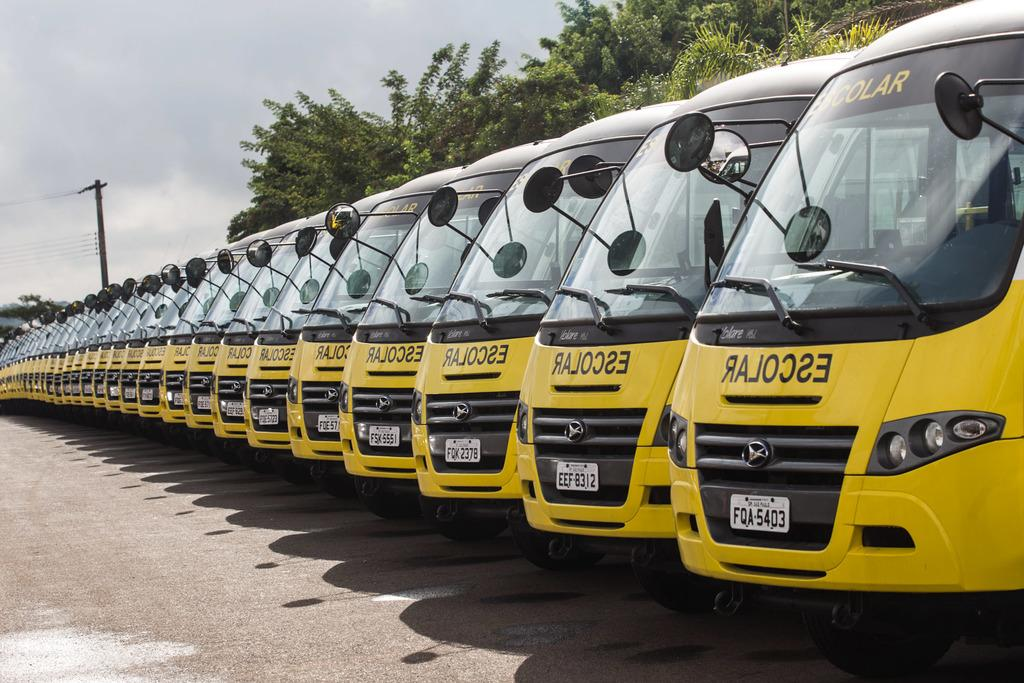What type of vehicles are in the image? There are buses in the image. What colors are the buses? The buses are in black and yellow color. What can be seen on the buses? Number-plates are visible in the image. What else is present in the image besides the buses? There are trees, current poles, wires, and the sky in the image. What is the color of the sky in the image? The sky is in white and blue color. What type of bomb can be seen in the image? There is no bomb present in the image. What subject is being taught in the image? There is no teaching or educational activity depicted in the image. 